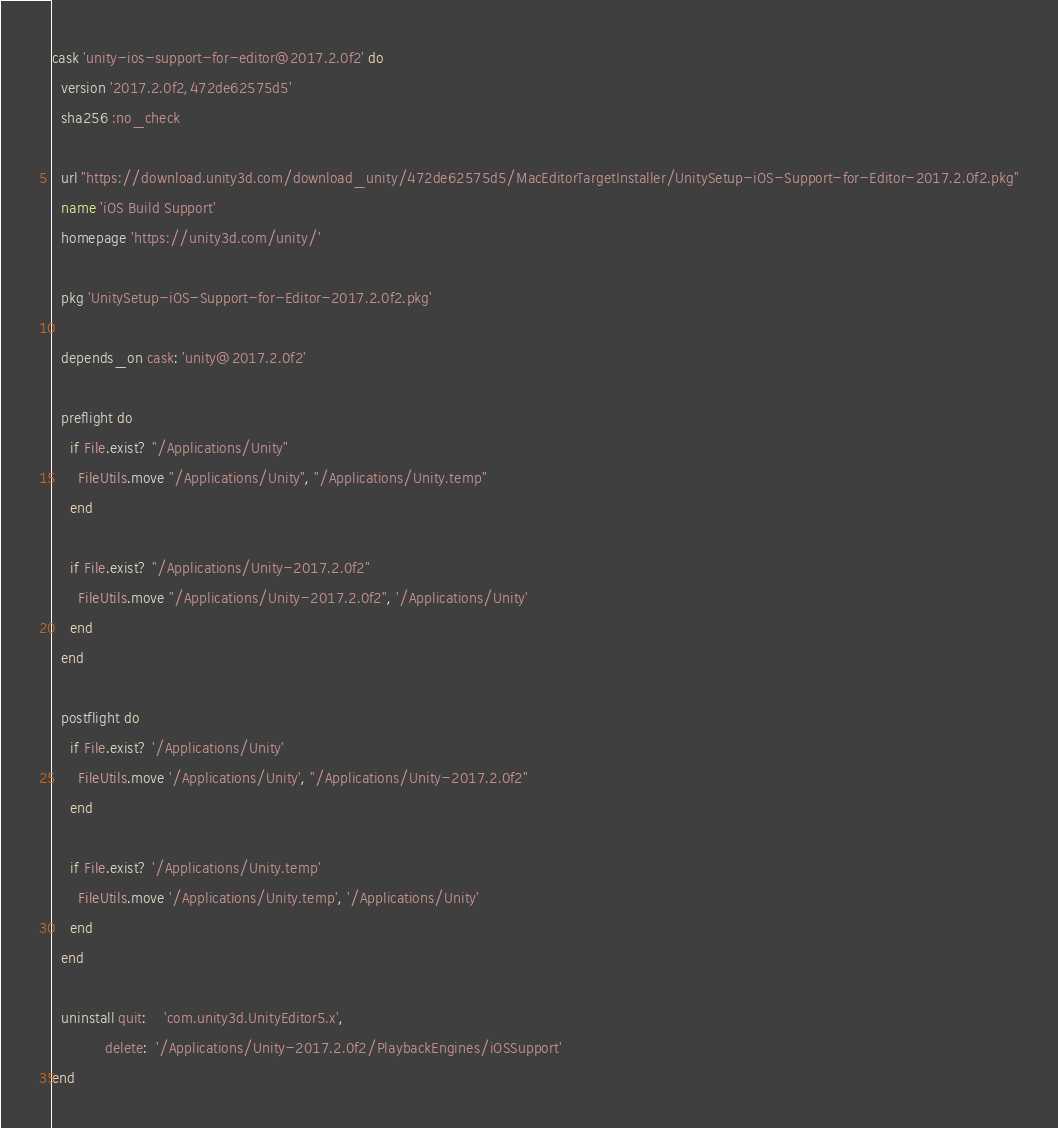<code> <loc_0><loc_0><loc_500><loc_500><_Ruby_>cask 'unity-ios-support-for-editor@2017.2.0f2' do
  version '2017.2.0f2,472de62575d5'
  sha256 :no_check

  url "https://download.unity3d.com/download_unity/472de62575d5/MacEditorTargetInstaller/UnitySetup-iOS-Support-for-Editor-2017.2.0f2.pkg"
  name 'iOS Build Support'
  homepage 'https://unity3d.com/unity/'

  pkg 'UnitySetup-iOS-Support-for-Editor-2017.2.0f2.pkg'

  depends_on cask: 'unity@2017.2.0f2'

  preflight do
    if File.exist? "/Applications/Unity"
      FileUtils.move "/Applications/Unity", "/Applications/Unity.temp"
    end

    if File.exist? "/Applications/Unity-2017.2.0f2"
      FileUtils.move "/Applications/Unity-2017.2.0f2", '/Applications/Unity'
    end
  end

  postflight do
    if File.exist? '/Applications/Unity'
      FileUtils.move '/Applications/Unity', "/Applications/Unity-2017.2.0f2"
    end

    if File.exist? '/Applications/Unity.temp'
      FileUtils.move '/Applications/Unity.temp', '/Applications/Unity'
    end
  end

  uninstall quit:    'com.unity3d.UnityEditor5.x',
            delete:  '/Applications/Unity-2017.2.0f2/PlaybackEngines/iOSSupport'
end
</code> 